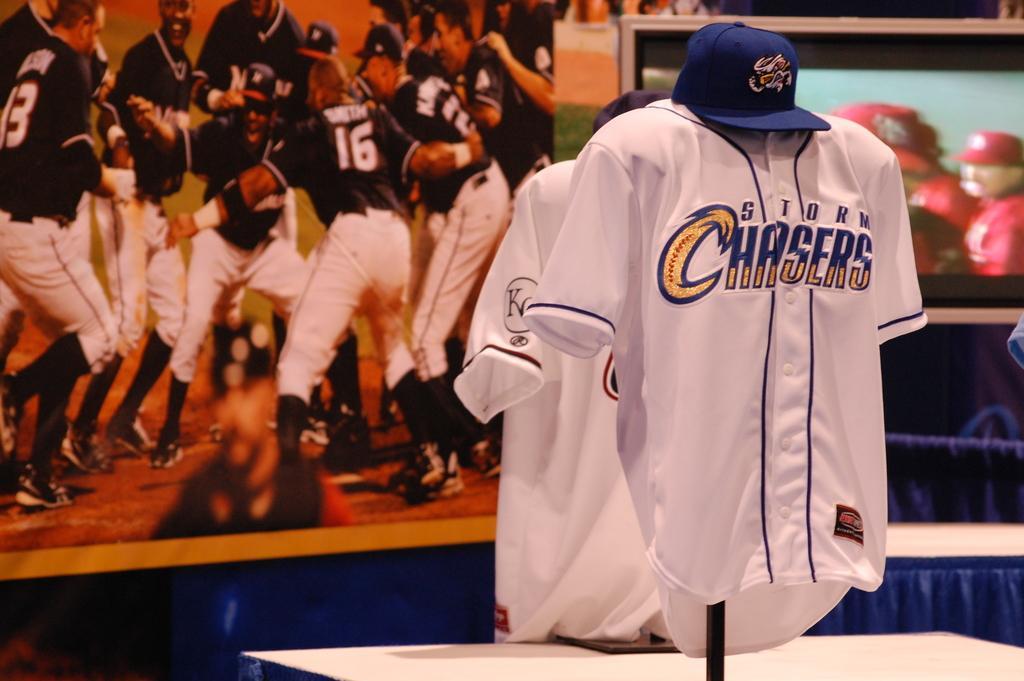Describe this image in one or two sentences. In this image there is a table, on that table there are two shirts and caps, in the background there is a poster on that poster there are players. 